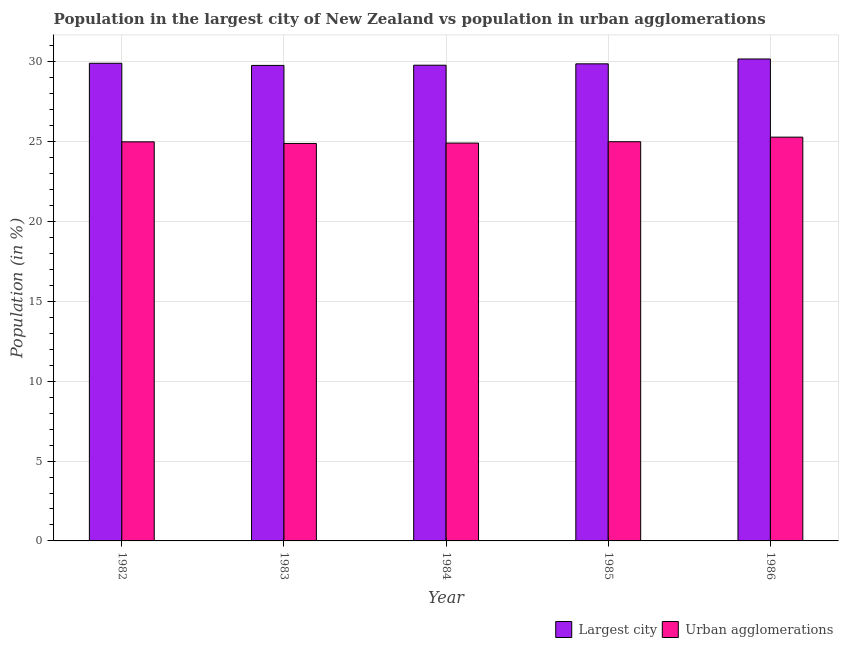How many groups of bars are there?
Give a very brief answer. 5. Are the number of bars per tick equal to the number of legend labels?
Make the answer very short. Yes. Are the number of bars on each tick of the X-axis equal?
Your answer should be compact. Yes. How many bars are there on the 4th tick from the left?
Your answer should be very brief. 2. How many bars are there on the 5th tick from the right?
Your answer should be very brief. 2. What is the label of the 1st group of bars from the left?
Your answer should be compact. 1982. In how many cases, is the number of bars for a given year not equal to the number of legend labels?
Offer a terse response. 0. What is the population in urban agglomerations in 1984?
Provide a short and direct response. 24.91. Across all years, what is the maximum population in urban agglomerations?
Provide a succinct answer. 25.28. Across all years, what is the minimum population in urban agglomerations?
Provide a succinct answer. 24.89. In which year was the population in the largest city maximum?
Provide a short and direct response. 1986. In which year was the population in the largest city minimum?
Offer a terse response. 1983. What is the total population in urban agglomerations in the graph?
Provide a succinct answer. 125.07. What is the difference between the population in the largest city in 1982 and that in 1983?
Provide a succinct answer. 0.13. What is the difference between the population in the largest city in 1986 and the population in urban agglomerations in 1984?
Offer a terse response. 0.39. What is the average population in urban agglomerations per year?
Offer a very short reply. 25.01. In the year 1986, what is the difference between the population in the largest city and population in urban agglomerations?
Offer a very short reply. 0. In how many years, is the population in the largest city greater than 8 %?
Offer a terse response. 5. What is the ratio of the population in the largest city in 1982 to that in 1985?
Provide a short and direct response. 1. Is the population in urban agglomerations in 1983 less than that in 1986?
Ensure brevity in your answer.  Yes. Is the difference between the population in the largest city in 1982 and 1984 greater than the difference between the population in urban agglomerations in 1982 and 1984?
Your answer should be compact. No. What is the difference between the highest and the second highest population in the largest city?
Your response must be concise. 0.27. What is the difference between the highest and the lowest population in the largest city?
Give a very brief answer. 0.4. In how many years, is the population in the largest city greater than the average population in the largest city taken over all years?
Your response must be concise. 2. Is the sum of the population in the largest city in 1982 and 1983 greater than the maximum population in urban agglomerations across all years?
Give a very brief answer. Yes. What does the 1st bar from the left in 1982 represents?
Offer a terse response. Largest city. What does the 1st bar from the right in 1983 represents?
Give a very brief answer. Urban agglomerations. Are all the bars in the graph horizontal?
Your answer should be very brief. No. How many legend labels are there?
Ensure brevity in your answer.  2. How are the legend labels stacked?
Keep it short and to the point. Horizontal. What is the title of the graph?
Make the answer very short. Population in the largest city of New Zealand vs population in urban agglomerations. Does "Malaria" appear as one of the legend labels in the graph?
Give a very brief answer. No. What is the label or title of the X-axis?
Provide a succinct answer. Year. What is the label or title of the Y-axis?
Keep it short and to the point. Population (in %). What is the Population (in %) of Largest city in 1982?
Make the answer very short. 29.91. What is the Population (in %) in Urban agglomerations in 1982?
Give a very brief answer. 24.99. What is the Population (in %) in Largest city in 1983?
Offer a very short reply. 29.78. What is the Population (in %) in Urban agglomerations in 1983?
Your answer should be very brief. 24.89. What is the Population (in %) in Largest city in 1984?
Offer a very short reply. 29.79. What is the Population (in %) of Urban agglomerations in 1984?
Your answer should be very brief. 24.91. What is the Population (in %) in Largest city in 1985?
Provide a short and direct response. 29.87. What is the Population (in %) in Urban agglomerations in 1985?
Offer a terse response. 25. What is the Population (in %) of Largest city in 1986?
Offer a very short reply. 30.18. What is the Population (in %) of Urban agglomerations in 1986?
Your response must be concise. 25.28. Across all years, what is the maximum Population (in %) of Largest city?
Your answer should be compact. 30.18. Across all years, what is the maximum Population (in %) in Urban agglomerations?
Your answer should be compact. 25.28. Across all years, what is the minimum Population (in %) of Largest city?
Offer a terse response. 29.78. Across all years, what is the minimum Population (in %) in Urban agglomerations?
Give a very brief answer. 24.89. What is the total Population (in %) of Largest city in the graph?
Give a very brief answer. 149.53. What is the total Population (in %) in Urban agglomerations in the graph?
Provide a short and direct response. 125.07. What is the difference between the Population (in %) of Largest city in 1982 and that in 1983?
Your response must be concise. 0.13. What is the difference between the Population (in %) in Urban agglomerations in 1982 and that in 1983?
Your answer should be very brief. 0.1. What is the difference between the Population (in %) in Largest city in 1982 and that in 1984?
Ensure brevity in your answer.  0.12. What is the difference between the Population (in %) of Urban agglomerations in 1982 and that in 1984?
Provide a succinct answer. 0.08. What is the difference between the Population (in %) of Largest city in 1982 and that in 1985?
Provide a short and direct response. 0.04. What is the difference between the Population (in %) in Urban agglomerations in 1982 and that in 1985?
Provide a short and direct response. -0.01. What is the difference between the Population (in %) of Largest city in 1982 and that in 1986?
Keep it short and to the point. -0.27. What is the difference between the Population (in %) in Urban agglomerations in 1982 and that in 1986?
Offer a terse response. -0.29. What is the difference between the Population (in %) in Largest city in 1983 and that in 1984?
Offer a very short reply. -0.01. What is the difference between the Population (in %) in Urban agglomerations in 1983 and that in 1984?
Your answer should be very brief. -0.02. What is the difference between the Population (in %) of Largest city in 1983 and that in 1985?
Ensure brevity in your answer.  -0.1. What is the difference between the Population (in %) in Urban agglomerations in 1983 and that in 1985?
Your answer should be compact. -0.11. What is the difference between the Population (in %) in Largest city in 1983 and that in 1986?
Your answer should be very brief. -0.4. What is the difference between the Population (in %) of Urban agglomerations in 1983 and that in 1986?
Offer a terse response. -0.39. What is the difference between the Population (in %) in Largest city in 1984 and that in 1985?
Make the answer very short. -0.09. What is the difference between the Population (in %) in Urban agglomerations in 1984 and that in 1985?
Offer a very short reply. -0.08. What is the difference between the Population (in %) in Largest city in 1984 and that in 1986?
Provide a short and direct response. -0.39. What is the difference between the Population (in %) in Urban agglomerations in 1984 and that in 1986?
Give a very brief answer. -0.37. What is the difference between the Population (in %) in Largest city in 1985 and that in 1986?
Give a very brief answer. -0.3. What is the difference between the Population (in %) in Urban agglomerations in 1985 and that in 1986?
Ensure brevity in your answer.  -0.29. What is the difference between the Population (in %) in Largest city in 1982 and the Population (in %) in Urban agglomerations in 1983?
Give a very brief answer. 5.02. What is the difference between the Population (in %) of Largest city in 1982 and the Population (in %) of Urban agglomerations in 1984?
Provide a short and direct response. 5. What is the difference between the Population (in %) in Largest city in 1982 and the Population (in %) in Urban agglomerations in 1985?
Your answer should be compact. 4.91. What is the difference between the Population (in %) of Largest city in 1982 and the Population (in %) of Urban agglomerations in 1986?
Your response must be concise. 4.63. What is the difference between the Population (in %) of Largest city in 1983 and the Population (in %) of Urban agglomerations in 1984?
Give a very brief answer. 4.86. What is the difference between the Population (in %) of Largest city in 1983 and the Population (in %) of Urban agglomerations in 1985?
Ensure brevity in your answer.  4.78. What is the difference between the Population (in %) of Largest city in 1983 and the Population (in %) of Urban agglomerations in 1986?
Provide a succinct answer. 4.49. What is the difference between the Population (in %) in Largest city in 1984 and the Population (in %) in Urban agglomerations in 1985?
Ensure brevity in your answer.  4.79. What is the difference between the Population (in %) of Largest city in 1984 and the Population (in %) of Urban agglomerations in 1986?
Your response must be concise. 4.5. What is the difference between the Population (in %) in Largest city in 1985 and the Population (in %) in Urban agglomerations in 1986?
Ensure brevity in your answer.  4.59. What is the average Population (in %) of Largest city per year?
Offer a very short reply. 29.91. What is the average Population (in %) of Urban agglomerations per year?
Provide a short and direct response. 25.01. In the year 1982, what is the difference between the Population (in %) of Largest city and Population (in %) of Urban agglomerations?
Provide a succinct answer. 4.92. In the year 1983, what is the difference between the Population (in %) of Largest city and Population (in %) of Urban agglomerations?
Make the answer very short. 4.89. In the year 1984, what is the difference between the Population (in %) in Largest city and Population (in %) in Urban agglomerations?
Give a very brief answer. 4.88. In the year 1985, what is the difference between the Population (in %) in Largest city and Population (in %) in Urban agglomerations?
Offer a terse response. 4.88. In the year 1986, what is the difference between the Population (in %) of Largest city and Population (in %) of Urban agglomerations?
Provide a succinct answer. 4.89. What is the ratio of the Population (in %) in Largest city in 1982 to that in 1983?
Make the answer very short. 1. What is the ratio of the Population (in %) in Urban agglomerations in 1982 to that in 1984?
Your answer should be compact. 1. What is the ratio of the Population (in %) in Largest city in 1982 to that in 1985?
Your answer should be compact. 1. What is the ratio of the Population (in %) in Urban agglomerations in 1982 to that in 1985?
Your response must be concise. 1. What is the ratio of the Population (in %) in Urban agglomerations in 1982 to that in 1986?
Give a very brief answer. 0.99. What is the ratio of the Population (in %) of Urban agglomerations in 1983 to that in 1984?
Provide a succinct answer. 1. What is the ratio of the Population (in %) of Largest city in 1983 to that in 1986?
Ensure brevity in your answer.  0.99. What is the ratio of the Population (in %) in Urban agglomerations in 1983 to that in 1986?
Offer a very short reply. 0.98. What is the ratio of the Population (in %) of Urban agglomerations in 1984 to that in 1985?
Keep it short and to the point. 1. What is the ratio of the Population (in %) of Largest city in 1984 to that in 1986?
Offer a terse response. 0.99. What is the ratio of the Population (in %) in Urban agglomerations in 1984 to that in 1986?
Provide a short and direct response. 0.99. What is the ratio of the Population (in %) of Largest city in 1985 to that in 1986?
Your response must be concise. 0.99. What is the ratio of the Population (in %) in Urban agglomerations in 1985 to that in 1986?
Give a very brief answer. 0.99. What is the difference between the highest and the second highest Population (in %) in Largest city?
Provide a short and direct response. 0.27. What is the difference between the highest and the second highest Population (in %) of Urban agglomerations?
Your response must be concise. 0.29. What is the difference between the highest and the lowest Population (in %) in Largest city?
Provide a succinct answer. 0.4. What is the difference between the highest and the lowest Population (in %) in Urban agglomerations?
Your answer should be very brief. 0.39. 